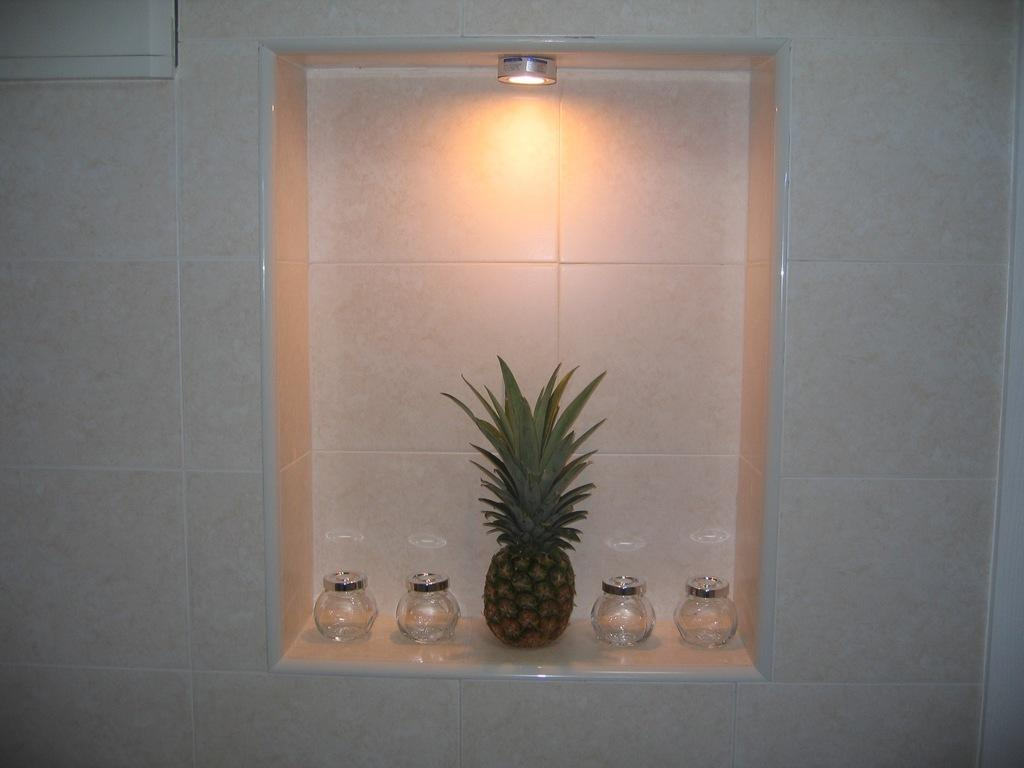What type of fruit is present in the image? There is a pineapple in the image. How many glass jars are visible in the image? There are four glass jars in the image. Where are the pineapple and glass jars located? The pineapple and glass jars are on a shelf. What is visible at the top of the image? There is a light at the top of the image. What type of square peace symbol can be seen in the image? There is no square peace symbol present in the image. How does the pineapple attract the attention of viewers in the image? The pineapple does not actively attract attention in the image; it is simply present on the shelf. 